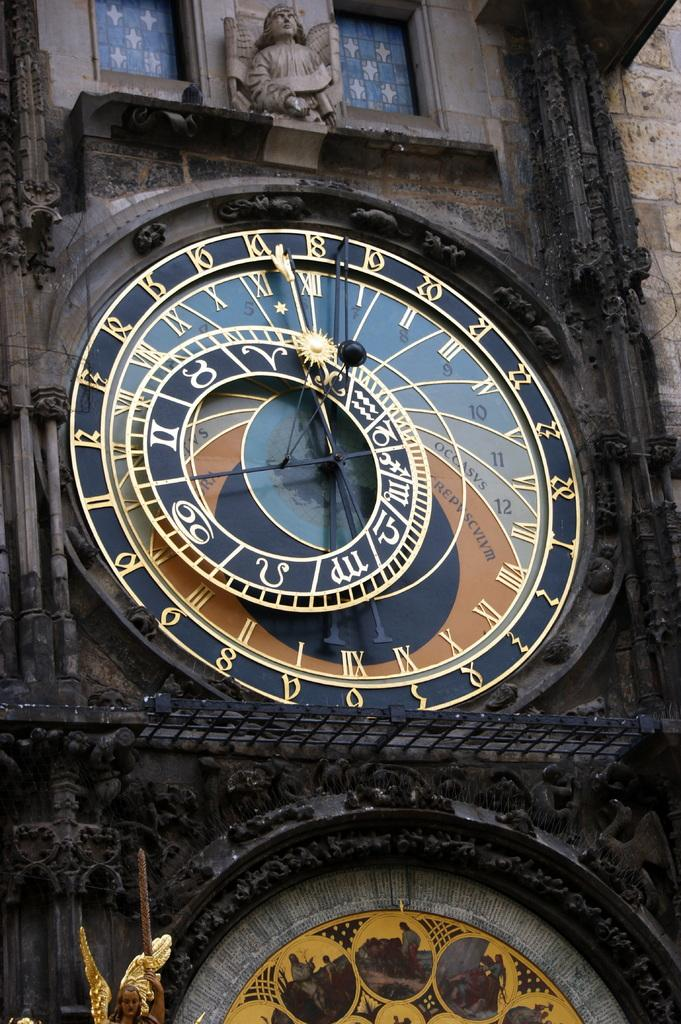What object can be seen on the wall of the building in the image? There is a clock on the wall of the building. What other feature is present on the building? There is a statue on the building. How many windows are there on either side of the statue? There are two windows on either side of the statue. What type of stamp can be seen on the statue in the image? There is no stamp present on the statue in the image. What material is the statue made of in the image? The provided facts do not mention the material of the statue, so we cannot definitively answer this question. 